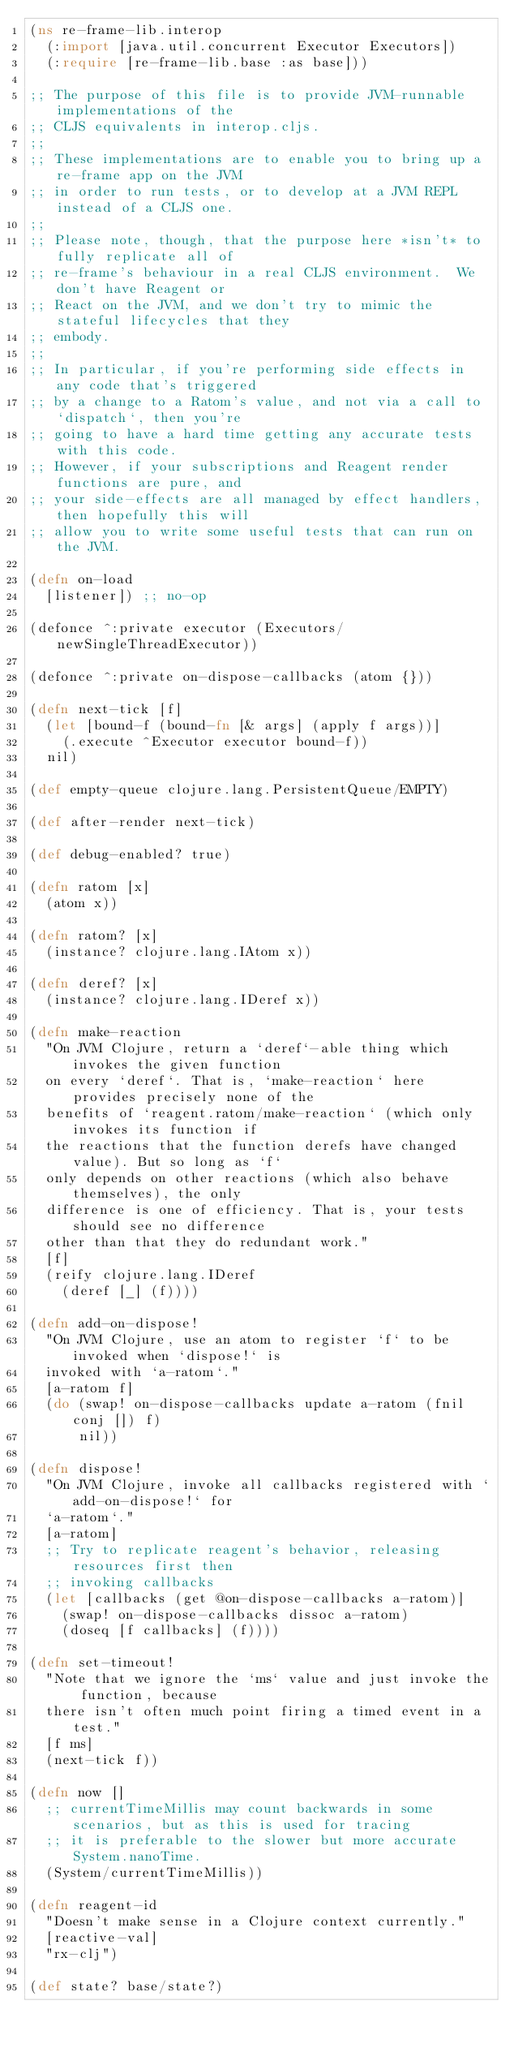Convert code to text. <code><loc_0><loc_0><loc_500><loc_500><_Clojure_>(ns re-frame-lib.interop
  (:import [java.util.concurrent Executor Executors])
  (:require [re-frame-lib.base :as base]))

;; The purpose of this file is to provide JVM-runnable implementations of the
;; CLJS equivalents in interop.cljs.
;;
;; These implementations are to enable you to bring up a re-frame app on the JVM
;; in order to run tests, or to develop at a JVM REPL instead of a CLJS one.
;;
;; Please note, though, that the purpose here *isn't* to fully replicate all of
;; re-frame's behaviour in a real CLJS environment.  We don't have Reagent or
;; React on the JVM, and we don't try to mimic the stateful lifecycles that they
;; embody.
;;
;; In particular, if you're performing side effects in any code that's triggered
;; by a change to a Ratom's value, and not via a call to `dispatch`, then you're
;; going to have a hard time getting any accurate tests with this code.
;; However, if your subscriptions and Reagent render functions are pure, and
;; your side-effects are all managed by effect handlers, then hopefully this will
;; allow you to write some useful tests that can run on the JVM.

(defn on-load
  [listener]) ;; no-op

(defonce ^:private executor (Executors/newSingleThreadExecutor))

(defonce ^:private on-dispose-callbacks (atom {}))

(defn next-tick [f]
  (let [bound-f (bound-fn [& args] (apply f args))]
    (.execute ^Executor executor bound-f))
  nil)

(def empty-queue clojure.lang.PersistentQueue/EMPTY)

(def after-render next-tick)

(def debug-enabled? true)

(defn ratom [x]
  (atom x))

(defn ratom? [x]
  (instance? clojure.lang.IAtom x))

(defn deref? [x]
  (instance? clojure.lang.IDeref x))

(defn make-reaction
  "On JVM Clojure, return a `deref`-able thing which invokes the given function
  on every `deref`. That is, `make-reaction` here provides precisely none of the
  benefits of `reagent.ratom/make-reaction` (which only invokes its function if
  the reactions that the function derefs have changed value). But so long as `f`
  only depends on other reactions (which also behave themselves), the only
  difference is one of efficiency. That is, your tests should see no difference
  other than that they do redundant work."
  [f]
  (reify clojure.lang.IDeref
    (deref [_] (f))))

(defn add-on-dispose!
  "On JVM Clojure, use an atom to register `f` to be invoked when `dispose!` is
  invoked with `a-ratom`."
  [a-ratom f]
  (do (swap! on-dispose-callbacks update a-ratom (fnil conj []) f)
      nil))

(defn dispose!
  "On JVM Clojure, invoke all callbacks registered with `add-on-dispose!` for
  `a-ratom`."
  [a-ratom]
  ;; Try to replicate reagent's behavior, releasing resources first then
  ;; invoking callbacks
  (let [callbacks (get @on-dispose-callbacks a-ratom)]
    (swap! on-dispose-callbacks dissoc a-ratom)
    (doseq [f callbacks] (f))))

(defn set-timeout!
  "Note that we ignore the `ms` value and just invoke the function, because
  there isn't often much point firing a timed event in a test."
  [f ms]
  (next-tick f))

(defn now []
  ;; currentTimeMillis may count backwards in some scenarios, but as this is used for tracing
  ;; it is preferable to the slower but more accurate System.nanoTime.
  (System/currentTimeMillis))

(defn reagent-id
  "Doesn't make sense in a Clojure context currently."
  [reactive-val]
  "rx-clj")

(def state? base/state?)
</code> 